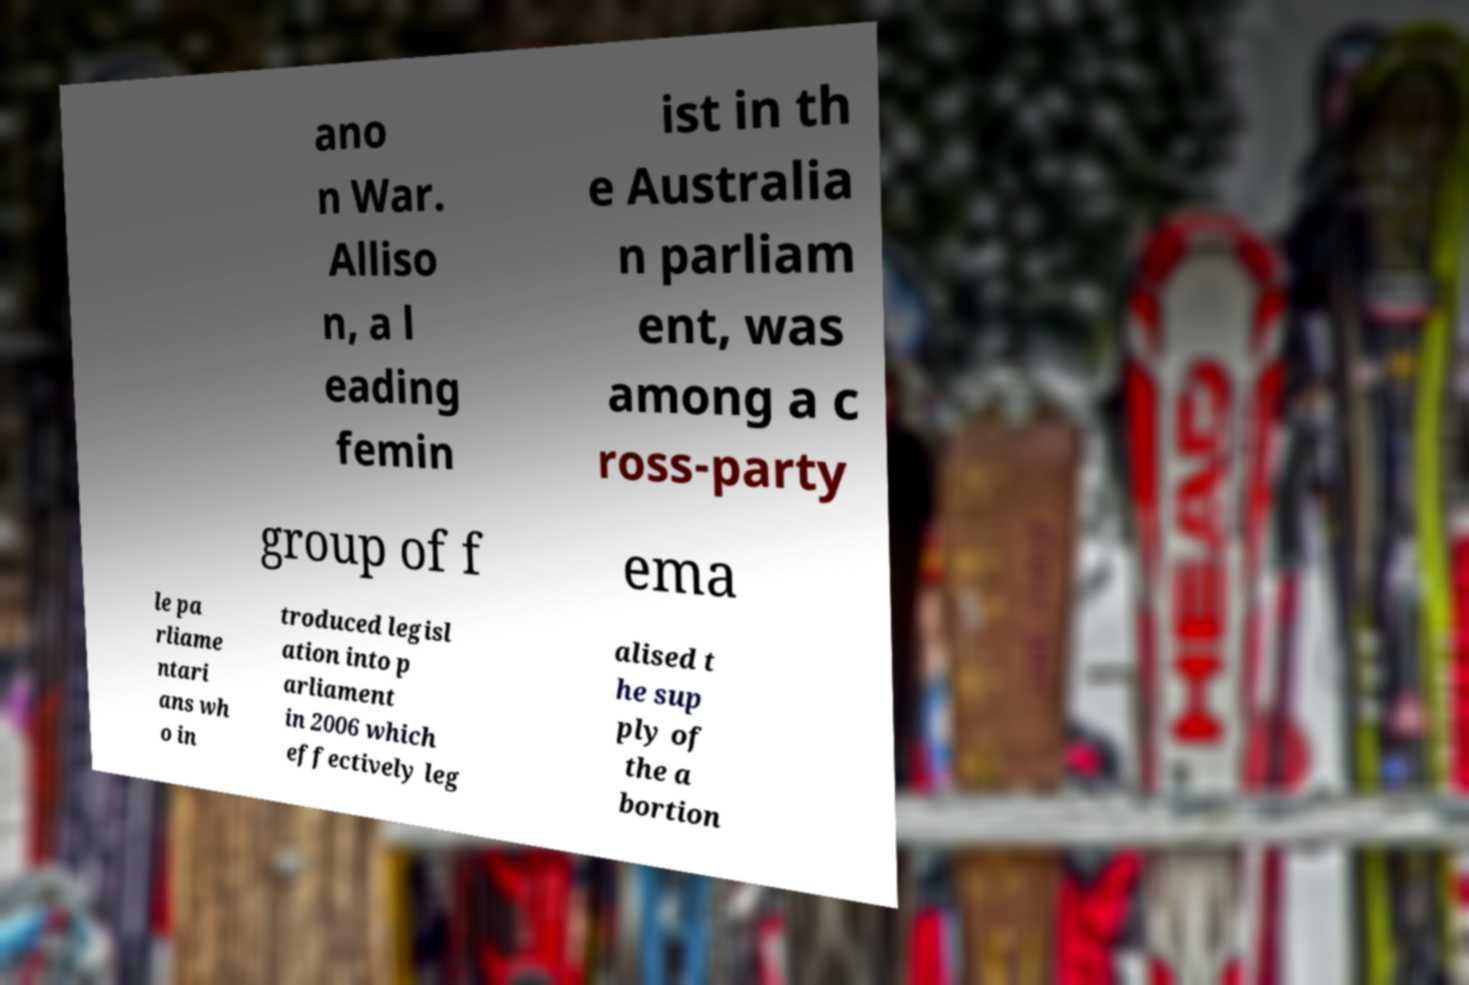What messages or text are displayed in this image? I need them in a readable, typed format. ano n War. Alliso n, a l eading femin ist in th e Australia n parliam ent, was among a c ross-party group of f ema le pa rliame ntari ans wh o in troduced legisl ation into p arliament in 2006 which effectively leg alised t he sup ply of the a bortion 